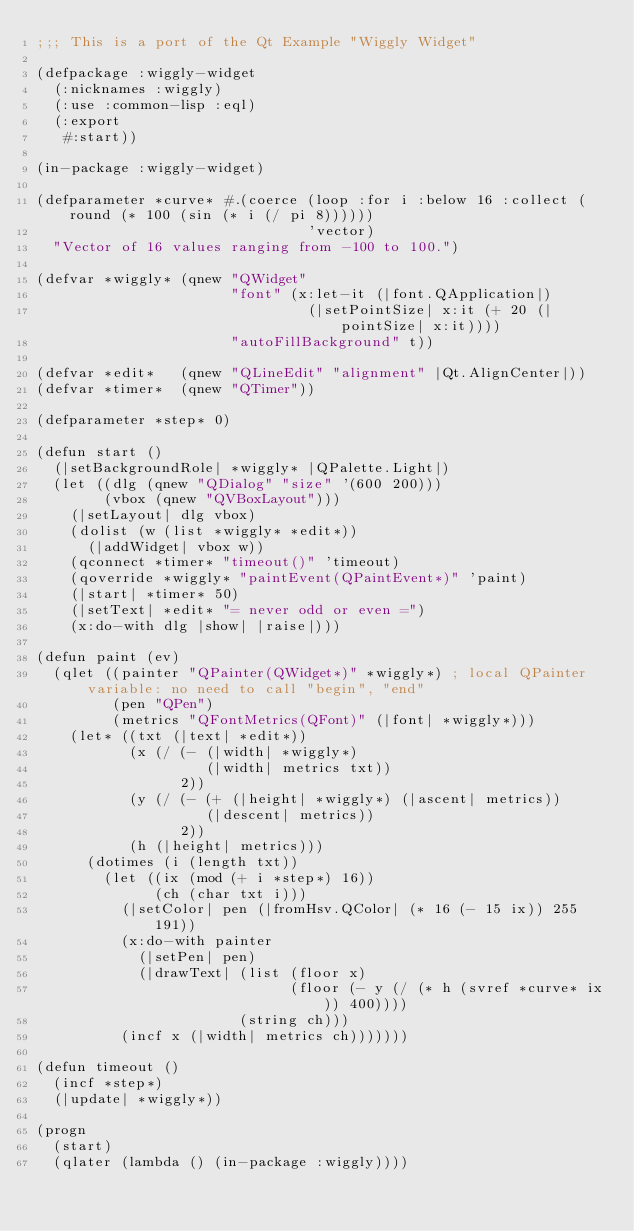<code> <loc_0><loc_0><loc_500><loc_500><_Lisp_>;;; This is a port of the Qt Example "Wiggly Widget"

(defpackage :wiggly-widget
  (:nicknames :wiggly)
  (:use :common-lisp :eql)
  (:export
   #:start))

(in-package :wiggly-widget)

(defparameter *curve* #.(coerce (loop :for i :below 16 :collect (round (* 100 (sin (* i (/ pi 8))))))
                                'vector)
  "Vector of 16 values ranging from -100 to 100.")

(defvar *wiggly* (qnew "QWidget"
                       "font" (x:let-it (|font.QApplication|)
                                (|setPointSize| x:it (+ 20 (|pointSize| x:it))))
                       "autoFillBackground" t))

(defvar *edit*   (qnew "QLineEdit" "alignment" |Qt.AlignCenter|))
(defvar *timer*  (qnew "QTimer"))

(defparameter *step* 0)

(defun start ()
  (|setBackgroundRole| *wiggly* |QPalette.Light|)
  (let ((dlg (qnew "QDialog" "size" '(600 200)))
        (vbox (qnew "QVBoxLayout")))
    (|setLayout| dlg vbox)
    (dolist (w (list *wiggly* *edit*))
      (|addWidget| vbox w))
    (qconnect *timer* "timeout()" 'timeout)
    (qoverride *wiggly* "paintEvent(QPaintEvent*)" 'paint)
    (|start| *timer* 50)
    (|setText| *edit* "= never odd or even =")
    (x:do-with dlg |show| |raise|)))

(defun paint (ev)
  (qlet ((painter "QPainter(QWidget*)" *wiggly*) ; local QPainter variable: no need to call "begin", "end"
         (pen "QPen")
         (metrics "QFontMetrics(QFont)" (|font| *wiggly*)))
    (let* ((txt (|text| *edit*))
           (x (/ (- (|width| *wiggly*)
                    (|width| metrics txt))
                 2))
           (y (/ (- (+ (|height| *wiggly*) (|ascent| metrics))
                    (|descent| metrics))
                 2))
           (h (|height| metrics)))
      (dotimes (i (length txt))
        (let ((ix (mod (+ i *step*) 16))
              (ch (char txt i)))
          (|setColor| pen (|fromHsv.QColor| (* 16 (- 15 ix)) 255 191))
          (x:do-with painter
            (|setPen| pen)
            (|drawText| (list (floor x)
                              (floor (- y (/ (* h (svref *curve* ix)) 400))))
                        (string ch)))
          (incf x (|width| metrics ch)))))))

(defun timeout ()
  (incf *step*)
  (|update| *wiggly*))

(progn
  (start)
  (qlater (lambda () (in-package :wiggly))))
</code> 